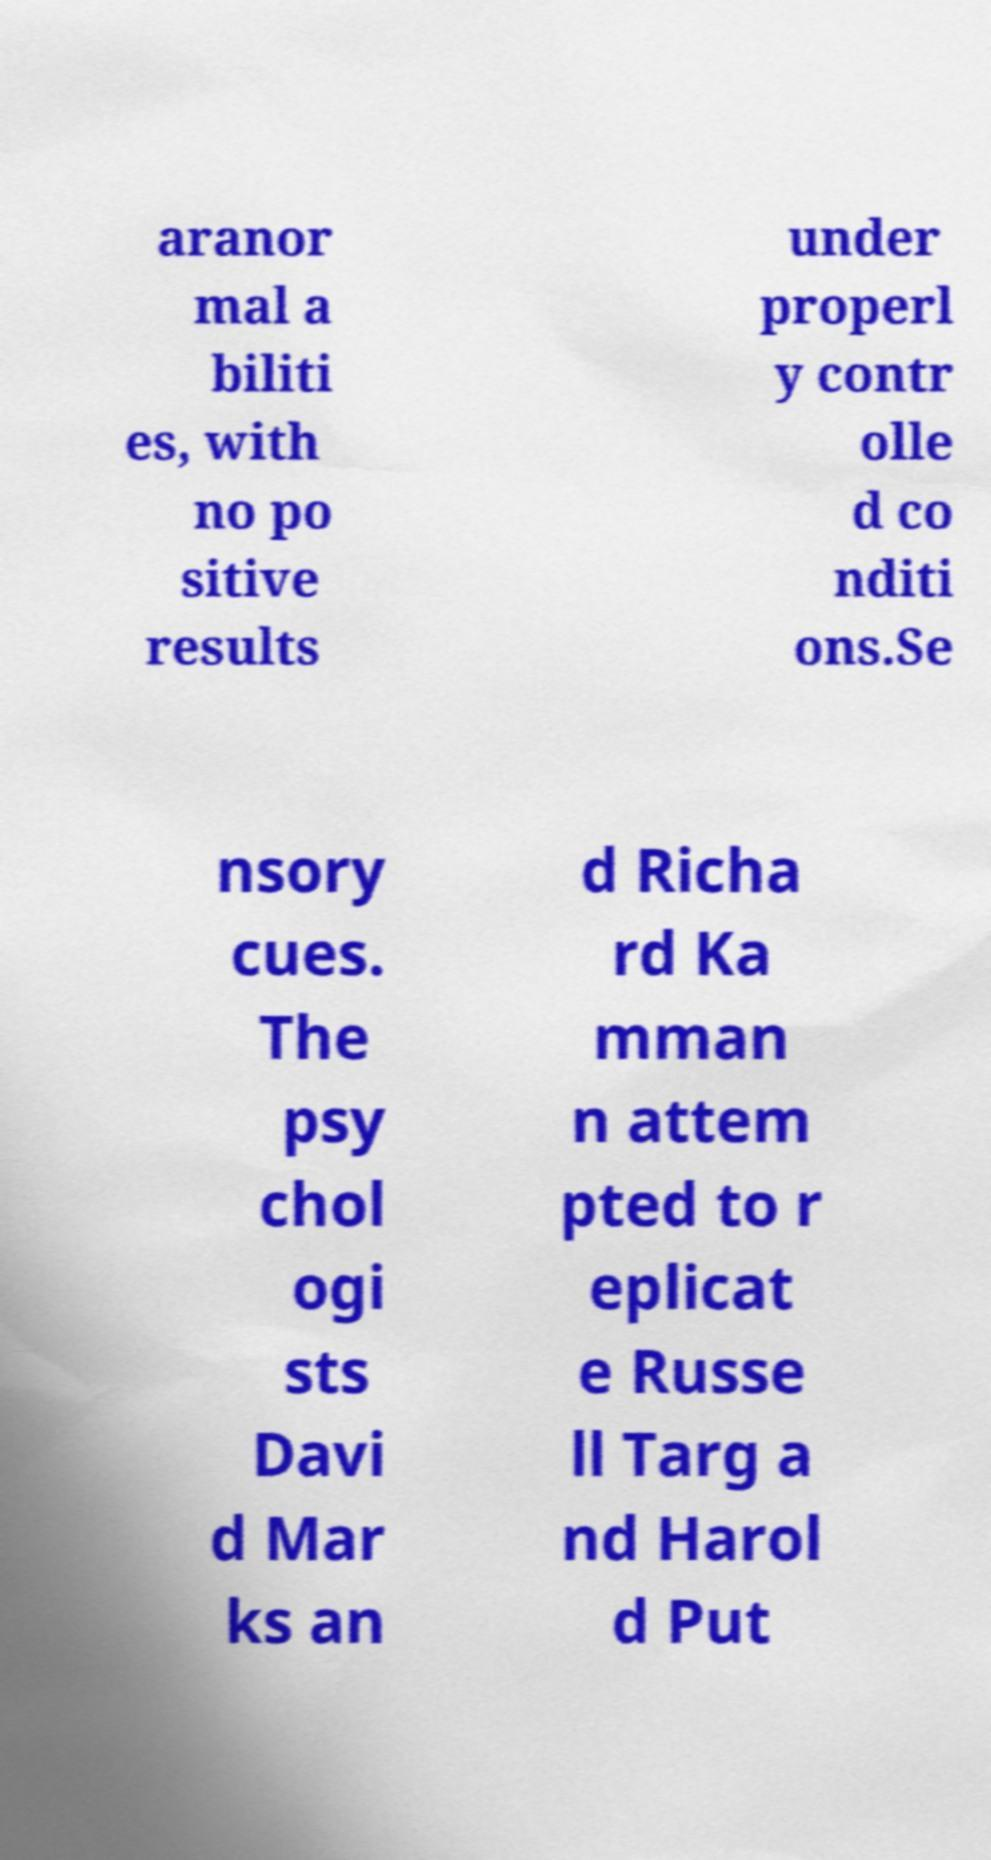There's text embedded in this image that I need extracted. Can you transcribe it verbatim? aranor mal a biliti es, with no po sitive results under properl y contr olle d co nditi ons.Se nsory cues. The psy chol ogi sts Davi d Mar ks an d Richa rd Ka mman n attem pted to r eplicat e Russe ll Targ a nd Harol d Put 